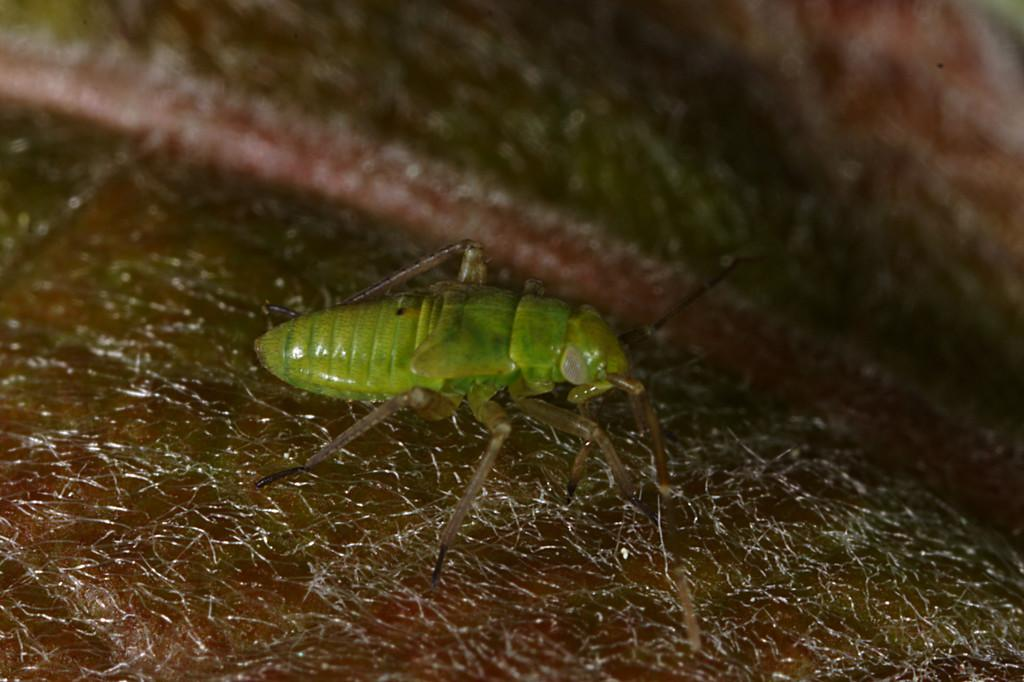What type of creature can be seen in the image? There is an insect in the image. Where is the insect located? The insect is on the ground. Can you describe the background of the image? The background of the image is blurred. What is the insect's profit from the division of labor in the image? There is no indication of division of labor or profit in the image, as it features an insect on the ground with a blurred background. 